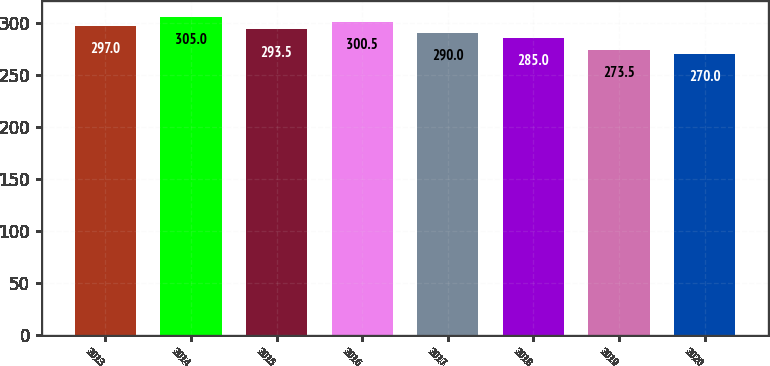<chart> <loc_0><loc_0><loc_500><loc_500><bar_chart><fcel>2013<fcel>2014<fcel>2015<fcel>2016<fcel>2017<fcel>2018<fcel>2019<fcel>2020<nl><fcel>297<fcel>305<fcel>293.5<fcel>300.5<fcel>290<fcel>285<fcel>273.5<fcel>270<nl></chart> 